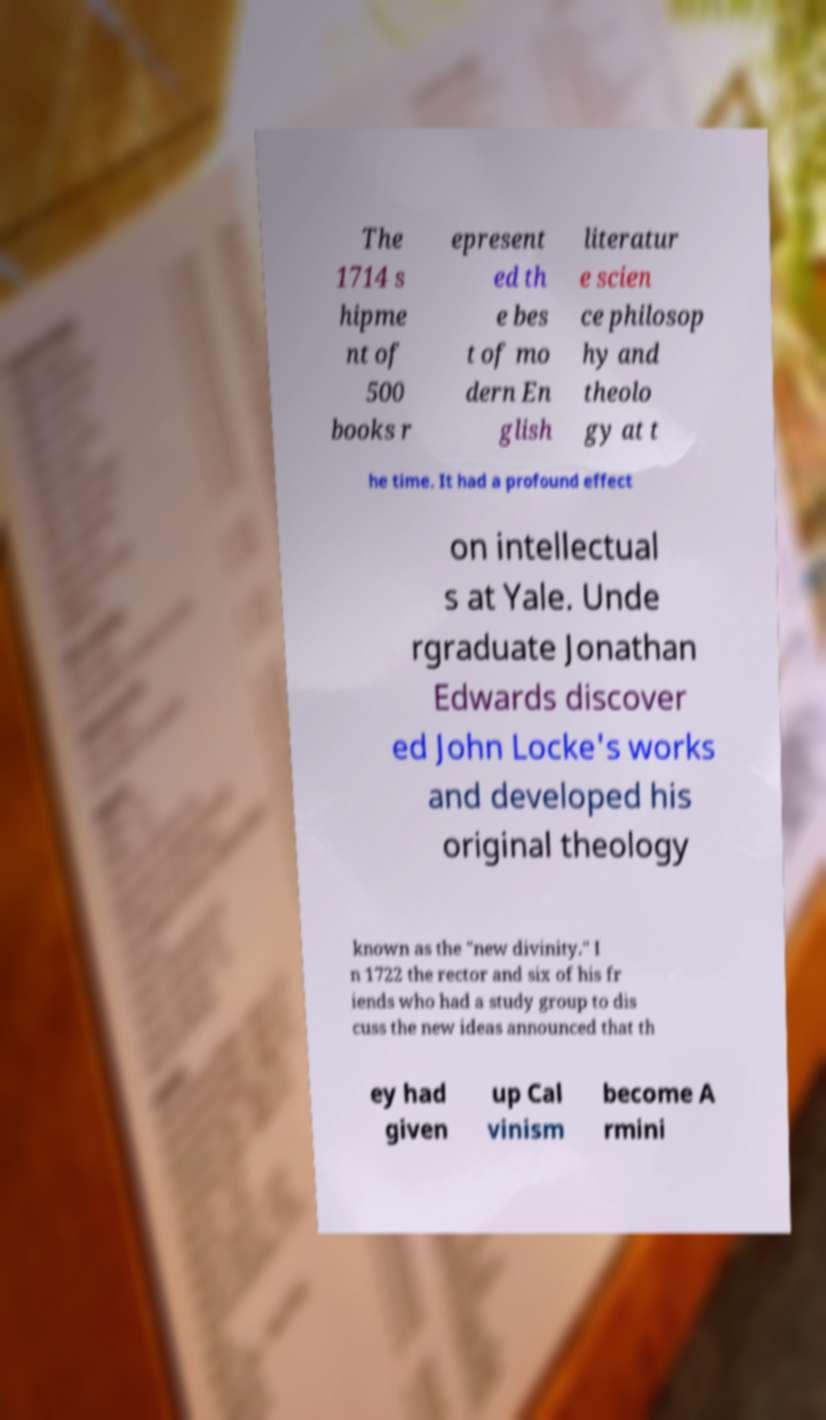Please read and relay the text visible in this image. What does it say? The 1714 s hipme nt of 500 books r epresent ed th e bes t of mo dern En glish literatur e scien ce philosop hy and theolo gy at t he time. It had a profound effect on intellectual s at Yale. Unde rgraduate Jonathan Edwards discover ed John Locke's works and developed his original theology known as the "new divinity." I n 1722 the rector and six of his fr iends who had a study group to dis cuss the new ideas announced that th ey had given up Cal vinism become A rmini 